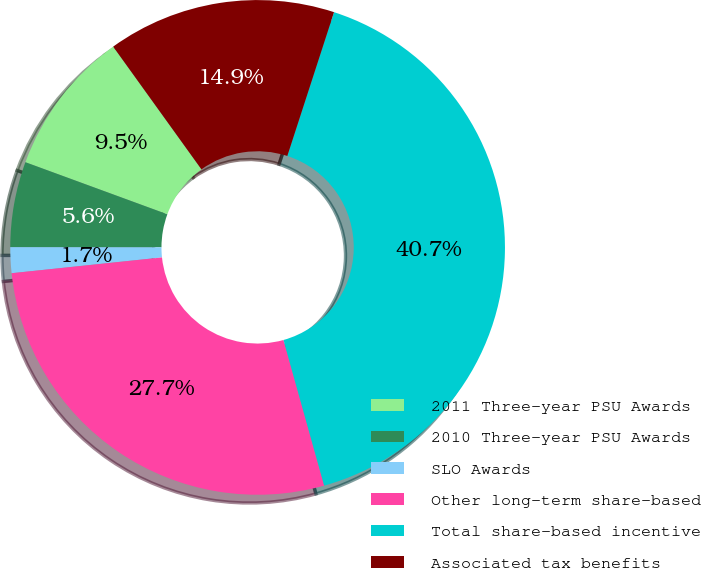Convert chart to OTSL. <chart><loc_0><loc_0><loc_500><loc_500><pie_chart><fcel>2011 Three-year PSU Awards<fcel>2010 Three-year PSU Awards<fcel>SLO Awards<fcel>Other long-term share-based<fcel>Total share-based incentive<fcel>Associated tax benefits<nl><fcel>9.48%<fcel>5.58%<fcel>1.68%<fcel>27.67%<fcel>40.66%<fcel>14.92%<nl></chart> 